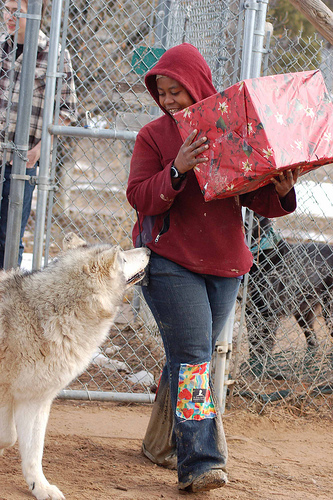<image>
Is there a dog behind the person? No. The dog is not behind the person. From this viewpoint, the dog appears to be positioned elsewhere in the scene. 